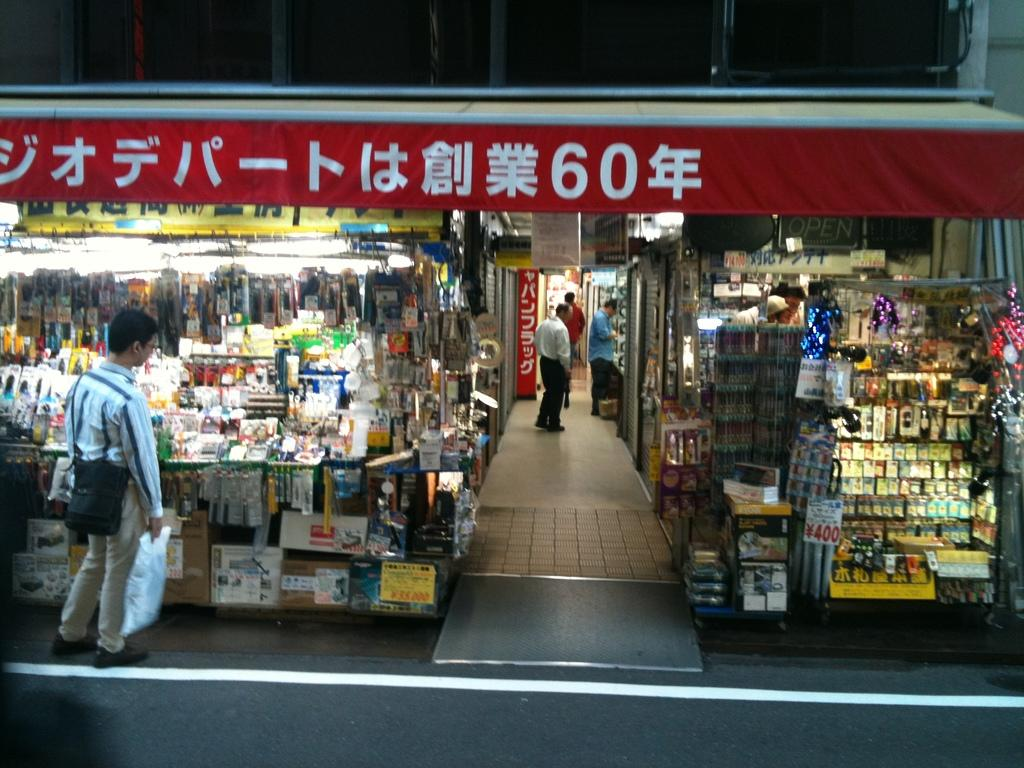Provide a one-sentence caption for the provided image. A man standing outside of a shopping mart with something written in Chinese on a banner above him including the number 60. 